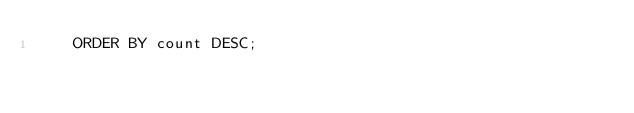Convert code to text. <code><loc_0><loc_0><loc_500><loc_500><_SQL_>    ORDER BY count DESC;
</code> 